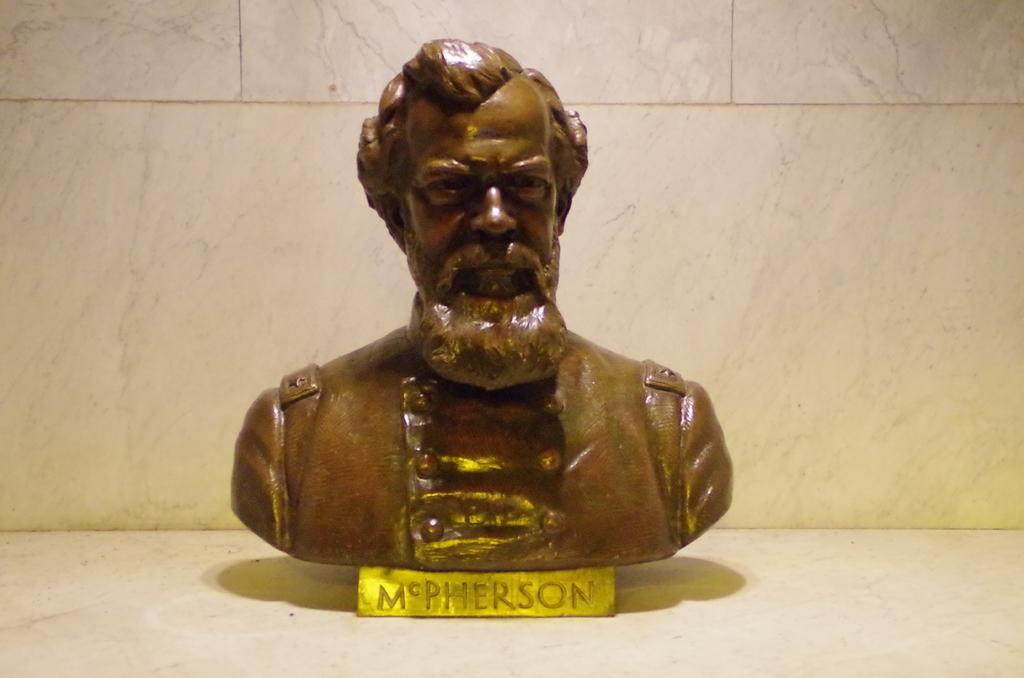What is the main subject of the image? There is a statue of a human in the image. What is the statue resting on? The statue is on a surface. What can be seen in the background of the image? There is a wall visible in the background of the image. How many sisters are swimming in the ocean in the image? There is no ocean or sisters present in the image; it features a statue of a human on a surface with a wall in the background. 